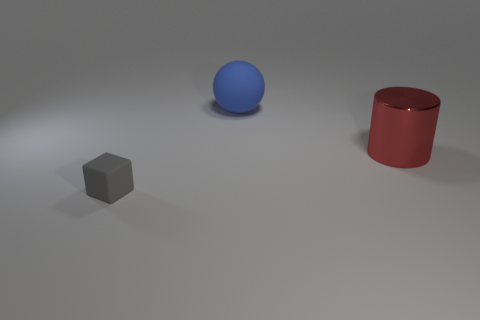What material do these objects appear to be made of, and how can you tell? The sphere and the cylindrical object both have a certain sheen and reflective quality to them, suggesting they could be made of a smooth, non-porous material like plastic or metal. The cube, on the other hand, lacks this reflective sheen and instead has a matte finish, which might indicate it is made of a more absorbent material such as rubber.  If I were to roll one of these objects, which would go the farthest? Given the shapes of the objects in the image, the sphere would likely roll the farthest. Its perfectly round shape offers the least resistance to motion on a flat surface, unlike the cube or cylinder which would both face interruptions to their motion due to their flat sides and faces. 